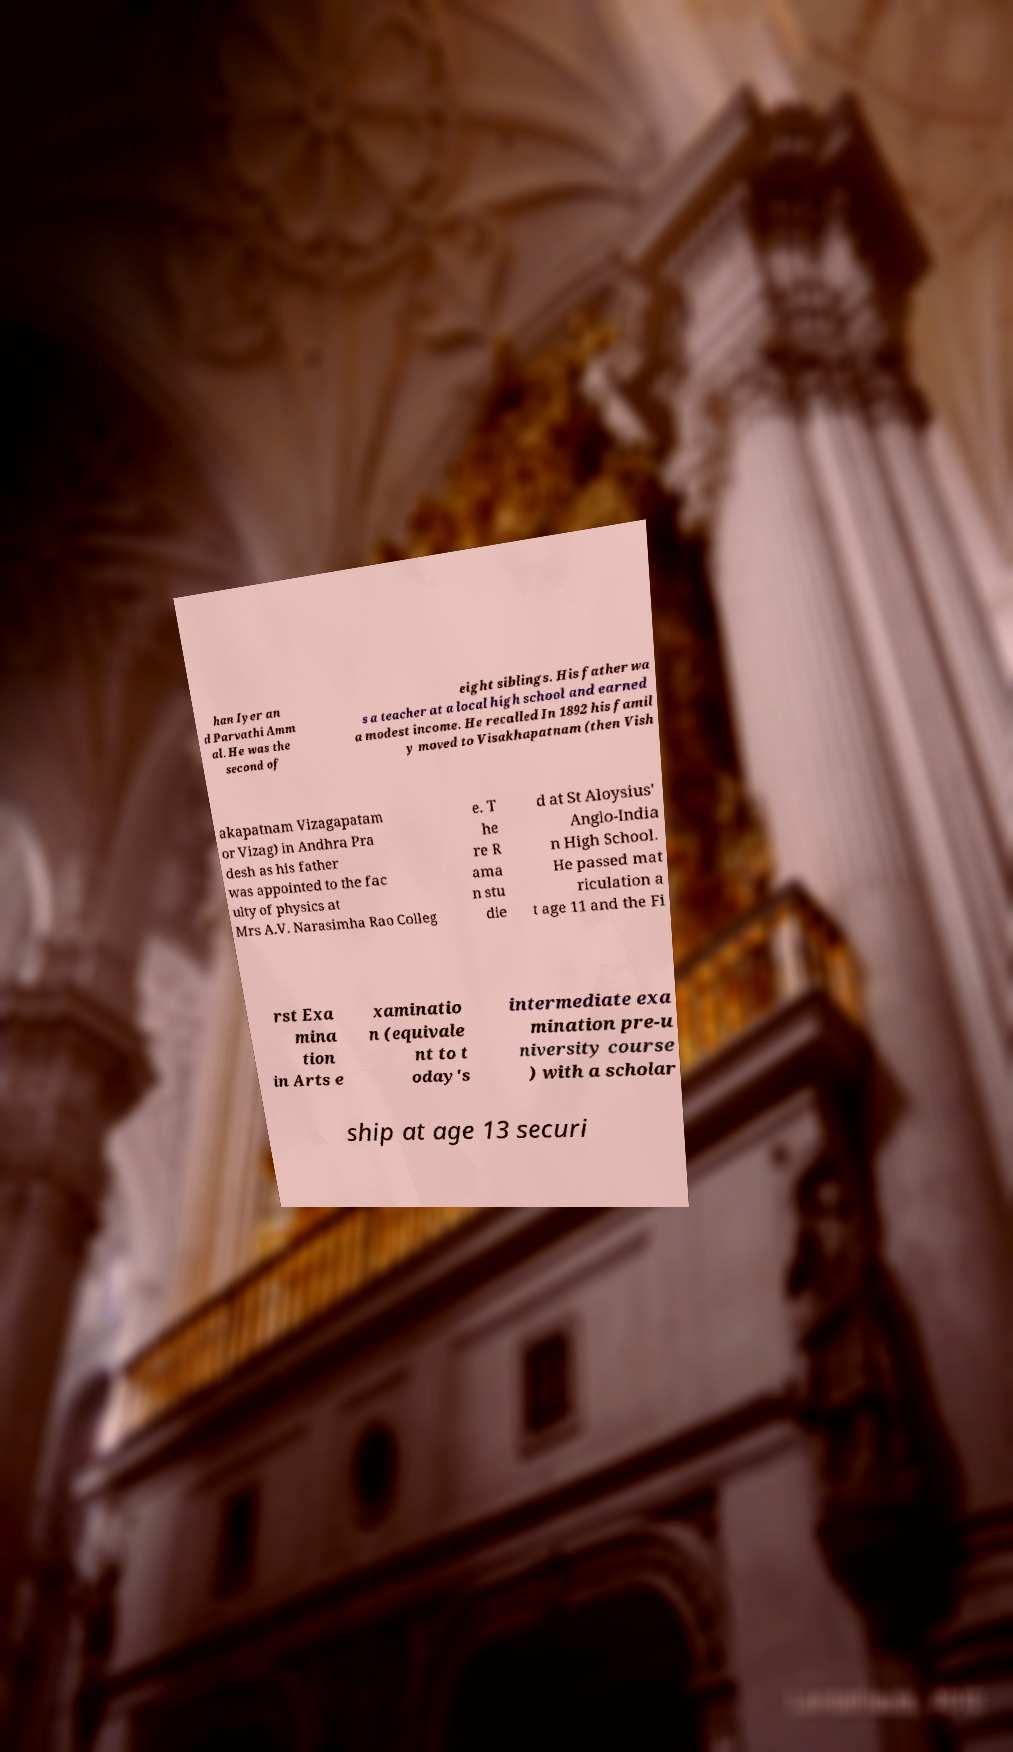For documentation purposes, I need the text within this image transcribed. Could you provide that? han Iyer an d Parvathi Amm al. He was the second of eight siblings. His father wa s a teacher at a local high school and earned a modest income. He recalled In 1892 his famil y moved to Visakhapatnam (then Vish akapatnam Vizagapatam or Vizag) in Andhra Pra desh as his father was appointed to the fac ulty of physics at Mrs A.V. Narasimha Rao Colleg e. T he re R ama n stu die d at St Aloysius' Anglo-India n High School. He passed mat riculation a t age 11 and the Fi rst Exa mina tion in Arts e xaminatio n (equivale nt to t oday's intermediate exa mination pre-u niversity course ) with a scholar ship at age 13 securi 